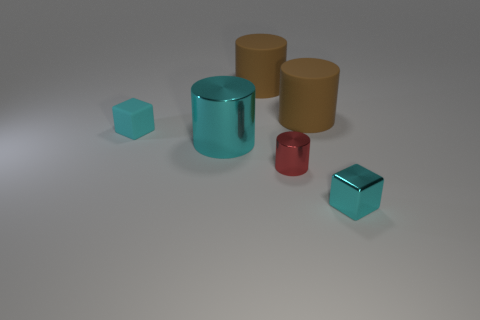There is another cyan block that is the same size as the cyan rubber cube; what material is it? metal 